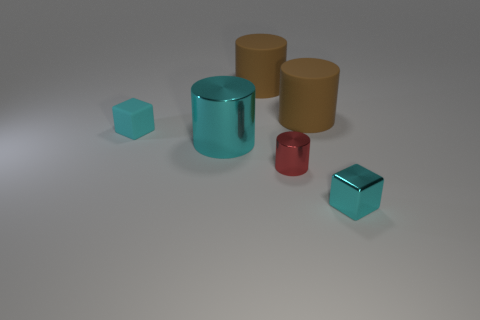There is another cyan block that is the same size as the cyan rubber cube; what material is it? metal 